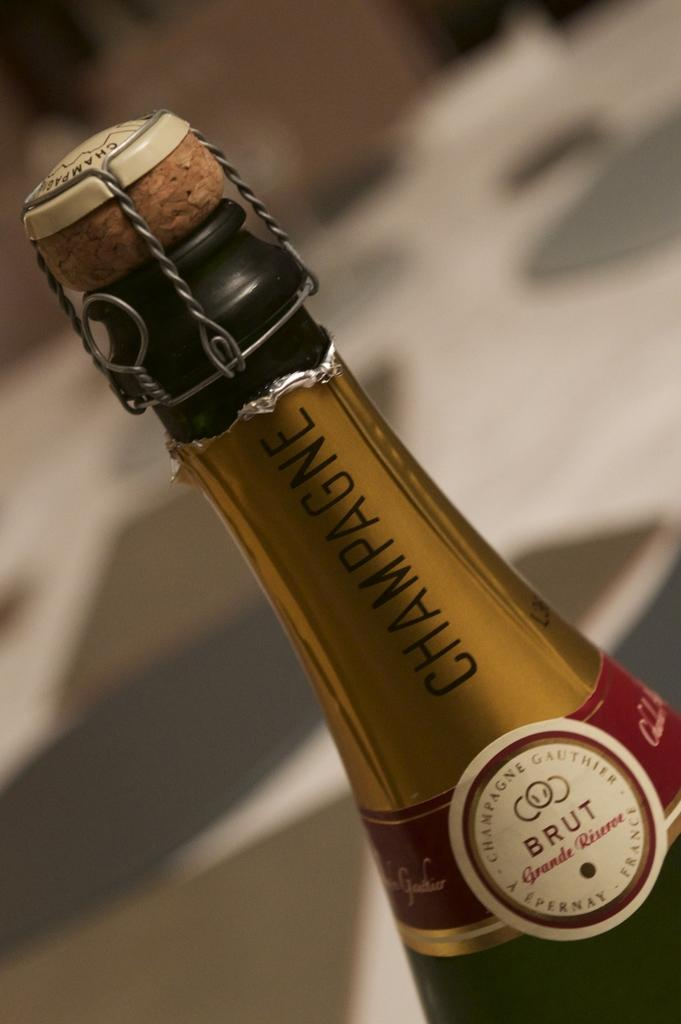<image>
Share a concise interpretation of the image provided. Bottle of champagne named BRUT that is still unopened. 